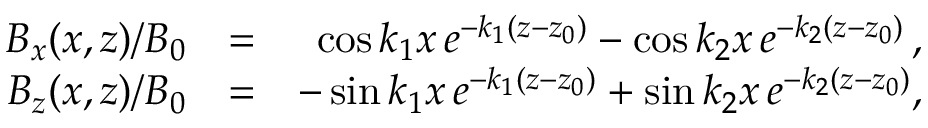<formula> <loc_0><loc_0><loc_500><loc_500>\begin{array} { r l r } { B _ { x } ( x , z ) / B _ { 0 } } & { = } & { \cos k _ { 1 } x \, e ^ { - k _ { 1 } ( z - z _ { 0 } ) } - \cos k _ { 2 } x \, e ^ { - k _ { 2 } ( z - z _ { 0 } ) } \, , } \\ { B _ { z } ( x , z ) / B _ { 0 } } & { = } & { - \sin k _ { 1 } x \, e ^ { - k _ { 1 } ( z - z _ { 0 } ) } + \sin k _ { 2 } x \, e ^ { - k _ { 2 } ( z - z _ { 0 } ) } , } \end{array}</formula> 